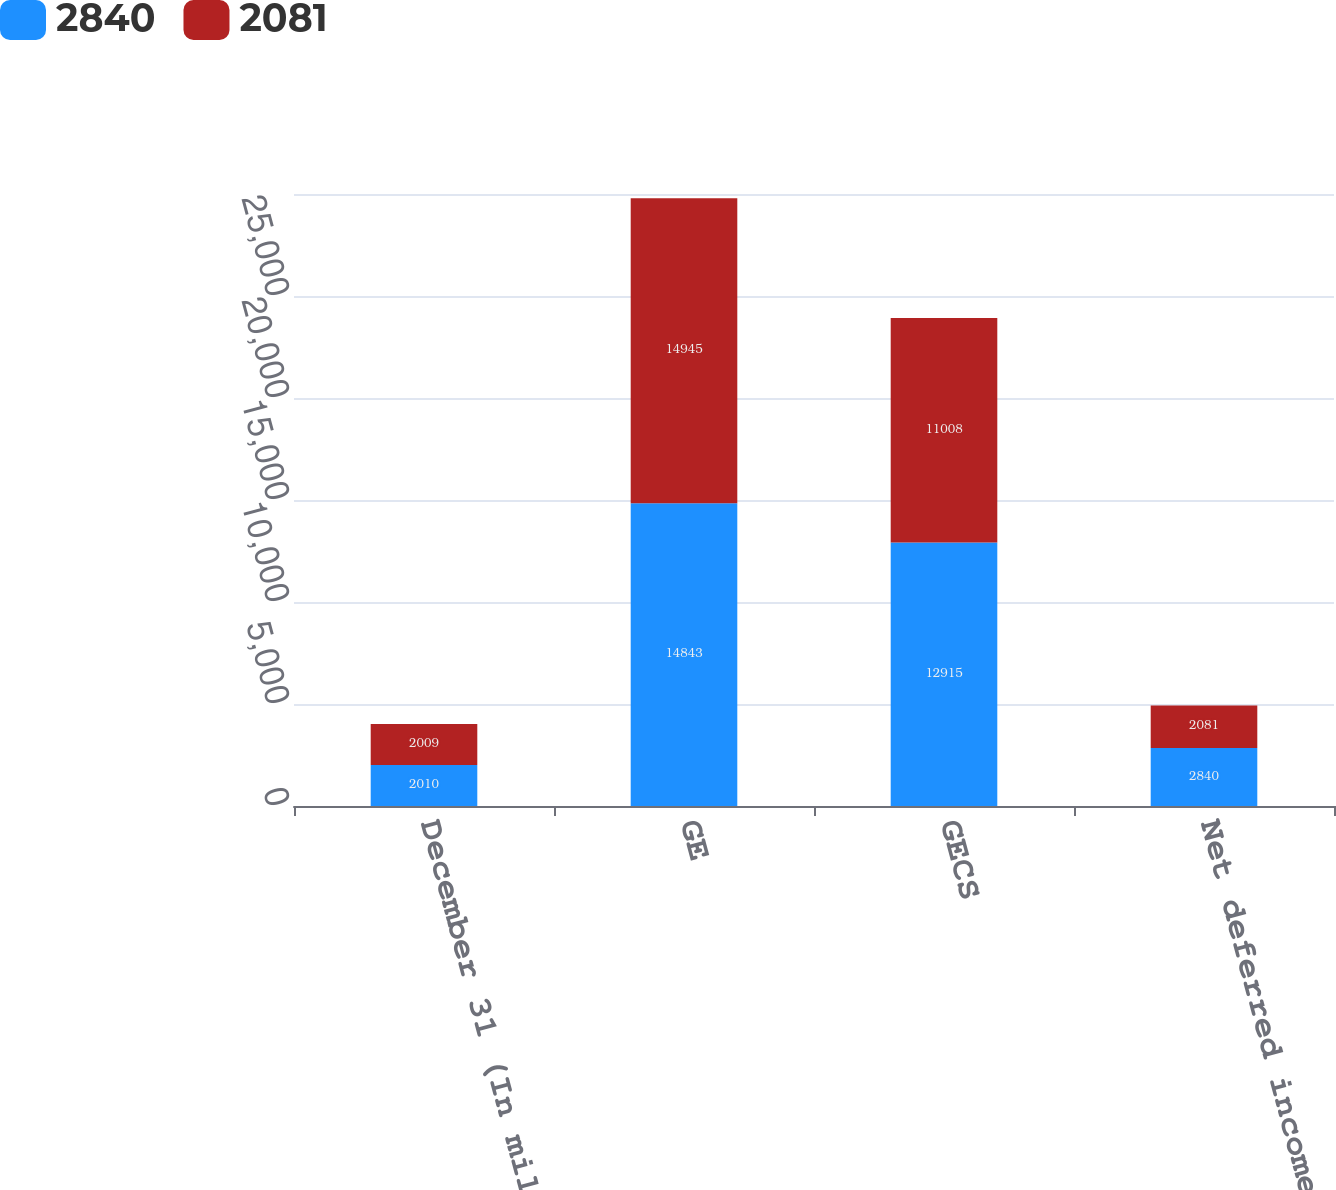Convert chart to OTSL. <chart><loc_0><loc_0><loc_500><loc_500><stacked_bar_chart><ecel><fcel>December 31 (In millions)<fcel>GE<fcel>GECS<fcel>Net deferred income tax<nl><fcel>2840<fcel>2010<fcel>14843<fcel>12915<fcel>2840<nl><fcel>2081<fcel>2009<fcel>14945<fcel>11008<fcel>2081<nl></chart> 